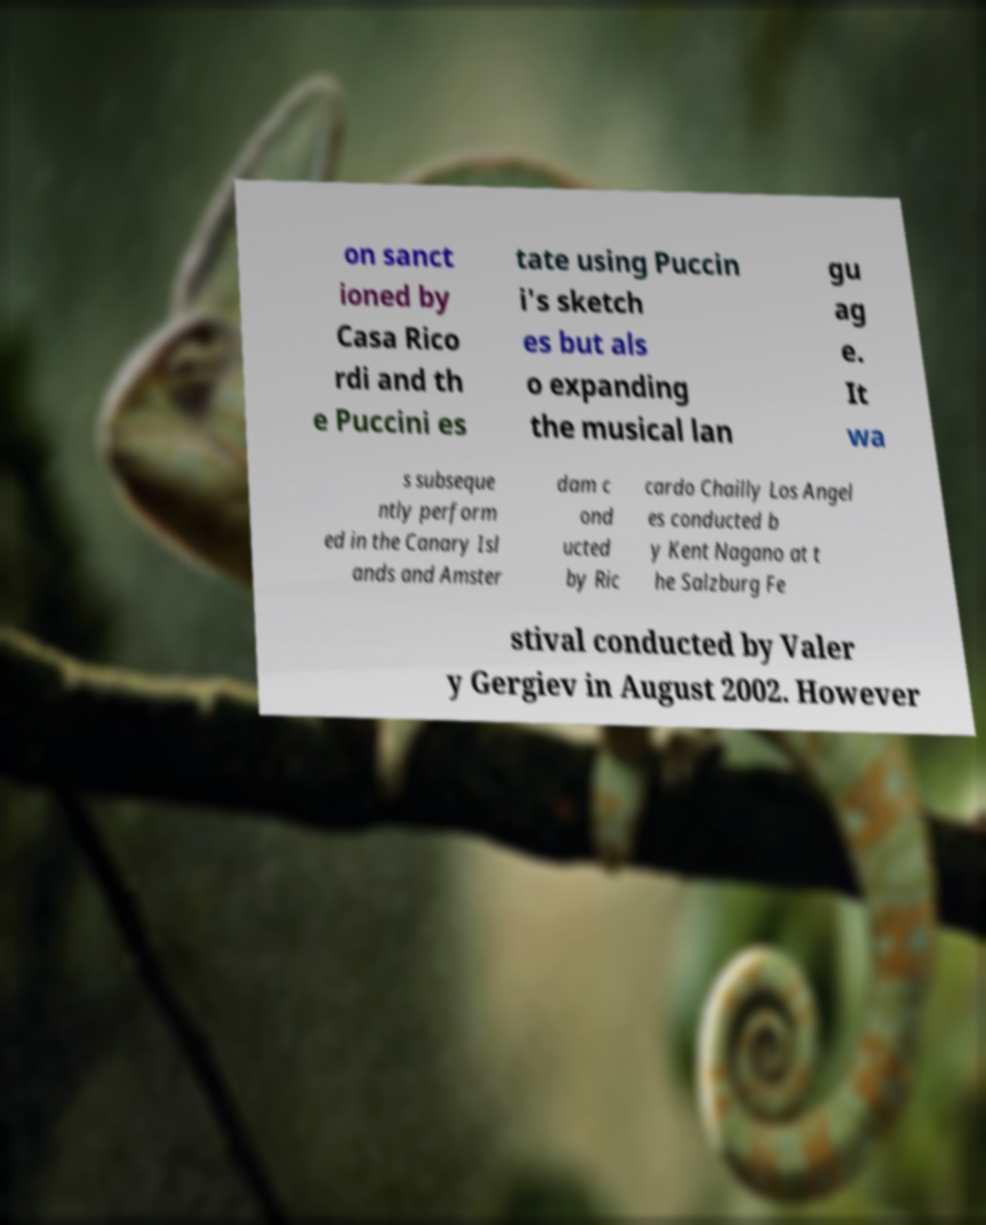There's text embedded in this image that I need extracted. Can you transcribe it verbatim? on sanct ioned by Casa Rico rdi and th e Puccini es tate using Puccin i's sketch es but als o expanding the musical lan gu ag e. It wa s subseque ntly perform ed in the Canary Isl ands and Amster dam c ond ucted by Ric cardo Chailly Los Angel es conducted b y Kent Nagano at t he Salzburg Fe stival conducted by Valer y Gergiev in August 2002. However 